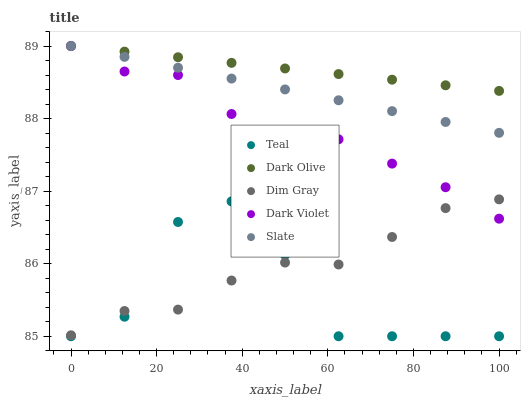Does Teal have the minimum area under the curve?
Answer yes or no. Yes. Does Dark Olive have the maximum area under the curve?
Answer yes or no. Yes. Does Dim Gray have the minimum area under the curve?
Answer yes or no. No. Does Dim Gray have the maximum area under the curve?
Answer yes or no. No. Is Slate the smoothest?
Answer yes or no. Yes. Is Teal the roughest?
Answer yes or no. Yes. Is Dim Gray the smoothest?
Answer yes or no. No. Is Dim Gray the roughest?
Answer yes or no. No. Does Teal have the lowest value?
Answer yes or no. Yes. Does Dim Gray have the lowest value?
Answer yes or no. No. Does Dark Violet have the highest value?
Answer yes or no. Yes. Does Dim Gray have the highest value?
Answer yes or no. No. Is Teal less than Dark Violet?
Answer yes or no. Yes. Is Slate greater than Teal?
Answer yes or no. Yes. Does Dark Violet intersect Slate?
Answer yes or no. Yes. Is Dark Violet less than Slate?
Answer yes or no. No. Is Dark Violet greater than Slate?
Answer yes or no. No. Does Teal intersect Dark Violet?
Answer yes or no. No. 